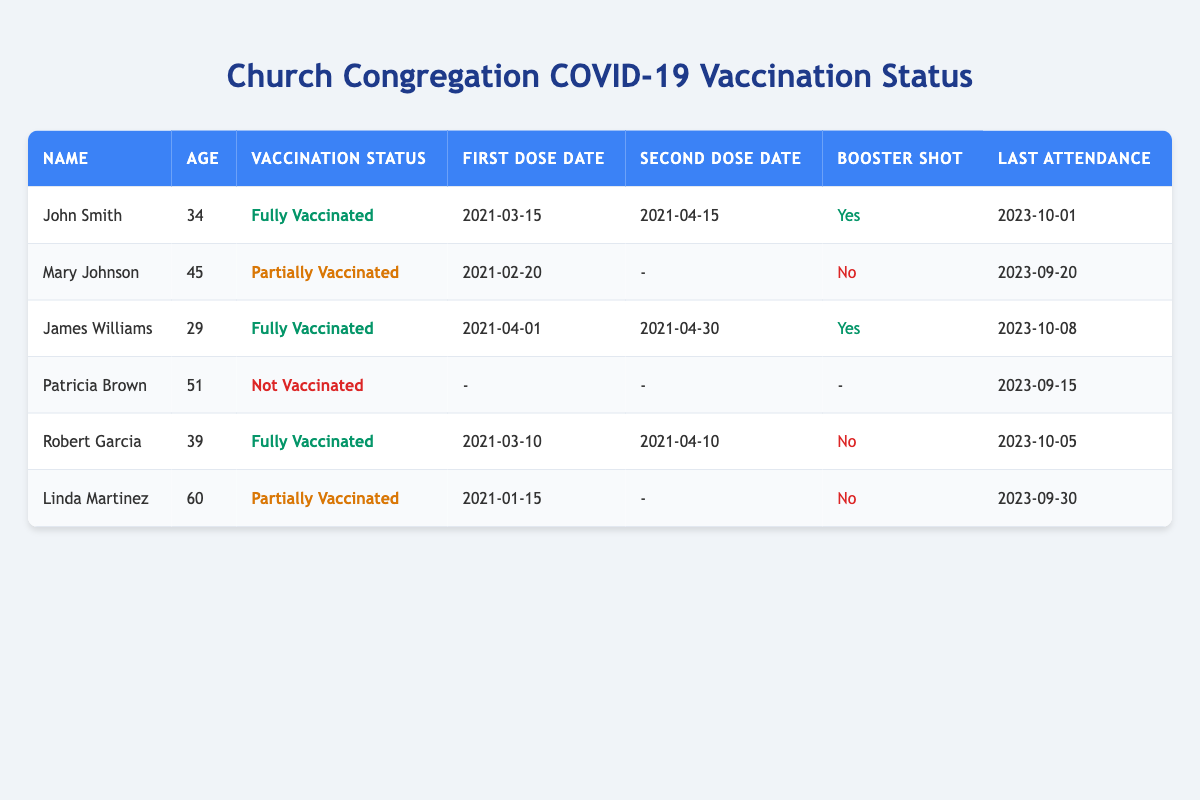What is the vaccination status of Mary Johnson? In the table, Mary Johnson's vaccination status is listed clearly under the "Vaccination Status" column. It shows that she is "Partially Vaccinated".
Answer: Partially Vaccinated How many members are fully vaccinated? By examining the "Vaccination Status" column, I count how many members are labeled "Fully Vaccinated". There are three members: John Smith, James Williams, and Robert Garcia.
Answer: 3 What is the age of the youngest fully vaccinated member? I first find the ages of fully vaccinated members: John Smith (34), James Williams (29), and Robert Garcia (39). I then identify that James Williams is the youngest at age 29.
Answer: 29 Is Linda Martinez's vaccination status fully vaccinated? Looking at the table, I see that Linda Martinez's vaccination status is listed as "Partially Vaccinated", which confirms she is not fully vaccinated.
Answer: No What is the average age of the congregation members who have received a booster shot? I identify the members who received a booster shot: John Smith (34), James Williams (29). Their ages are 34 and 29. To find the average age: (34 + 29) / 2 = 31.5.
Answer: 31.5 Which member has the most recent attendance date? I compare the "Last Attendance" dates in the table. The most recent date is 2023-10-08, attributed to James Williams.
Answer: James Williams How many members are not vaccinated at all? I refer to the "Vaccination Status" column and count how many are labeled "Not Vaccinated". There is only one member: Patricia Brown.
Answer: 1 What is the date of the second dose for John Smith? From the table, I see under "Second Dose Date" that John Smith's second dose was administered on 2021-04-15.
Answer: 2021-04-15 How many members attended church in September 2023? I look at the "Last Attendance" dates and see that Mary Johnson (2023-09-20), Patricia Brown (2023-09-15), and Linda Martinez (2023-09-30) all attended in September 2023. This totals to three members.
Answer: 3 